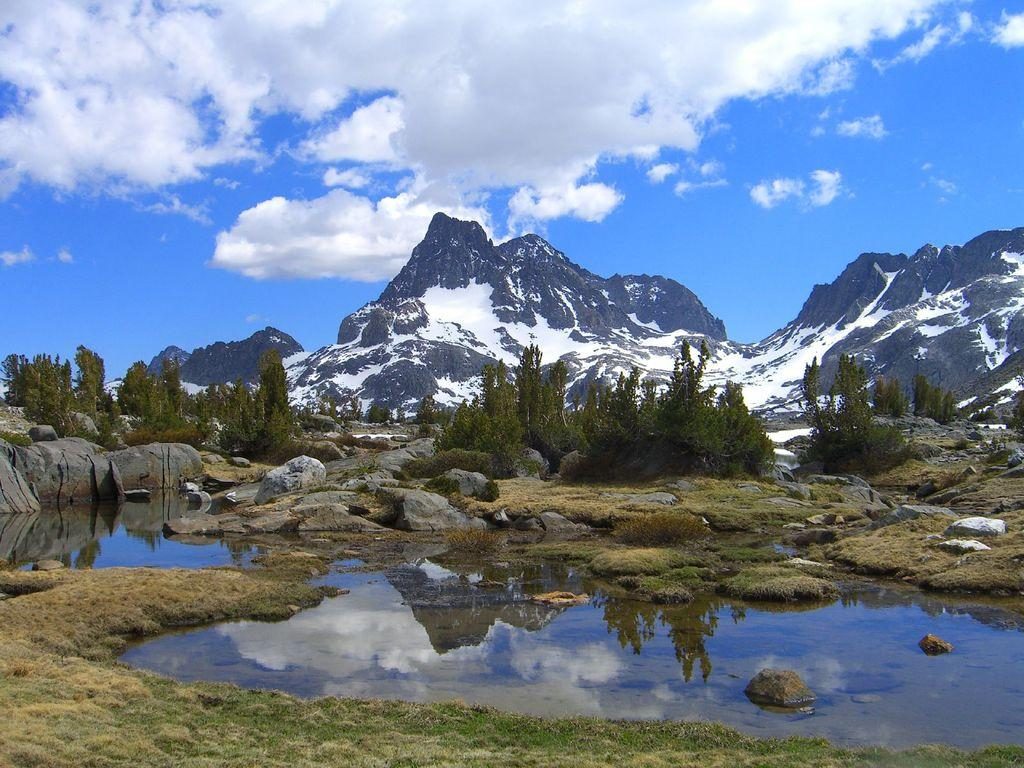What is located in the middle of the surface in the image? There is water in the middle of the surface in the image. What type of natural features can be seen in the image? There are rocks, trees, and mountains in the image. What is visible in the background of the image? The sky is visible in the image. How many accounts are visible in the image? There are no accounts present in the image; it features natural elements such as water, rocks, trees, mountains, and the sky. 